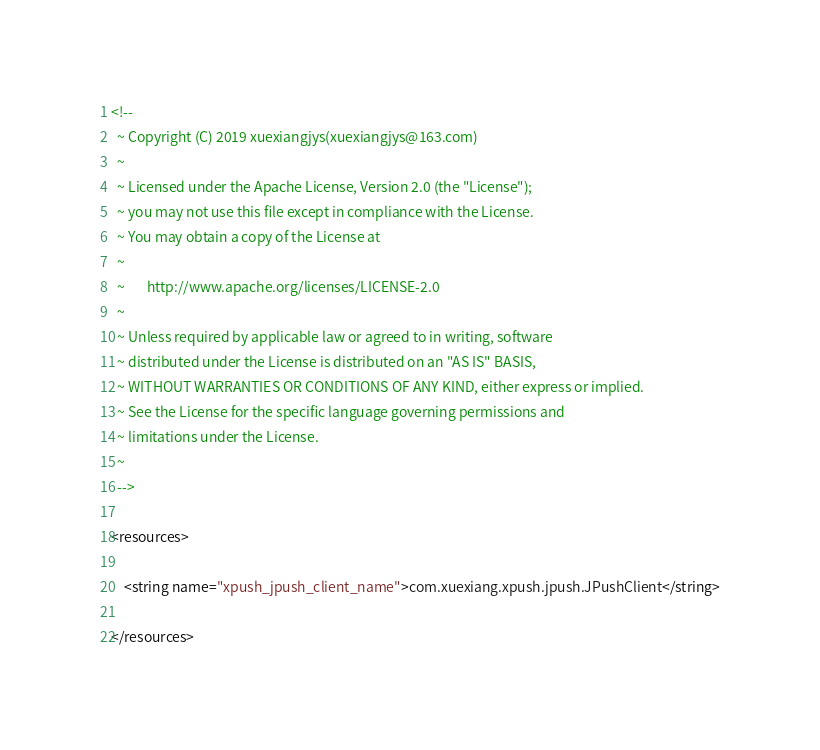<code> <loc_0><loc_0><loc_500><loc_500><_XML_><!--
  ~ Copyright (C) 2019 xuexiangjys(xuexiangjys@163.com)
  ~
  ~ Licensed under the Apache License, Version 2.0 (the "License");
  ~ you may not use this file except in compliance with the License.
  ~ You may obtain a copy of the License at
  ~
  ~       http://www.apache.org/licenses/LICENSE-2.0
  ~
  ~ Unless required by applicable law or agreed to in writing, software
  ~ distributed under the License is distributed on an "AS IS" BASIS,
  ~ WITHOUT WARRANTIES OR CONDITIONS OF ANY KIND, either express or implied.
  ~ See the License for the specific language governing permissions and
  ~ limitations under the License.
  ~
  -->

<resources>

    <string name="xpush_jpush_client_name">com.xuexiang.xpush.jpush.JPushClient</string>

</resources>
</code> 